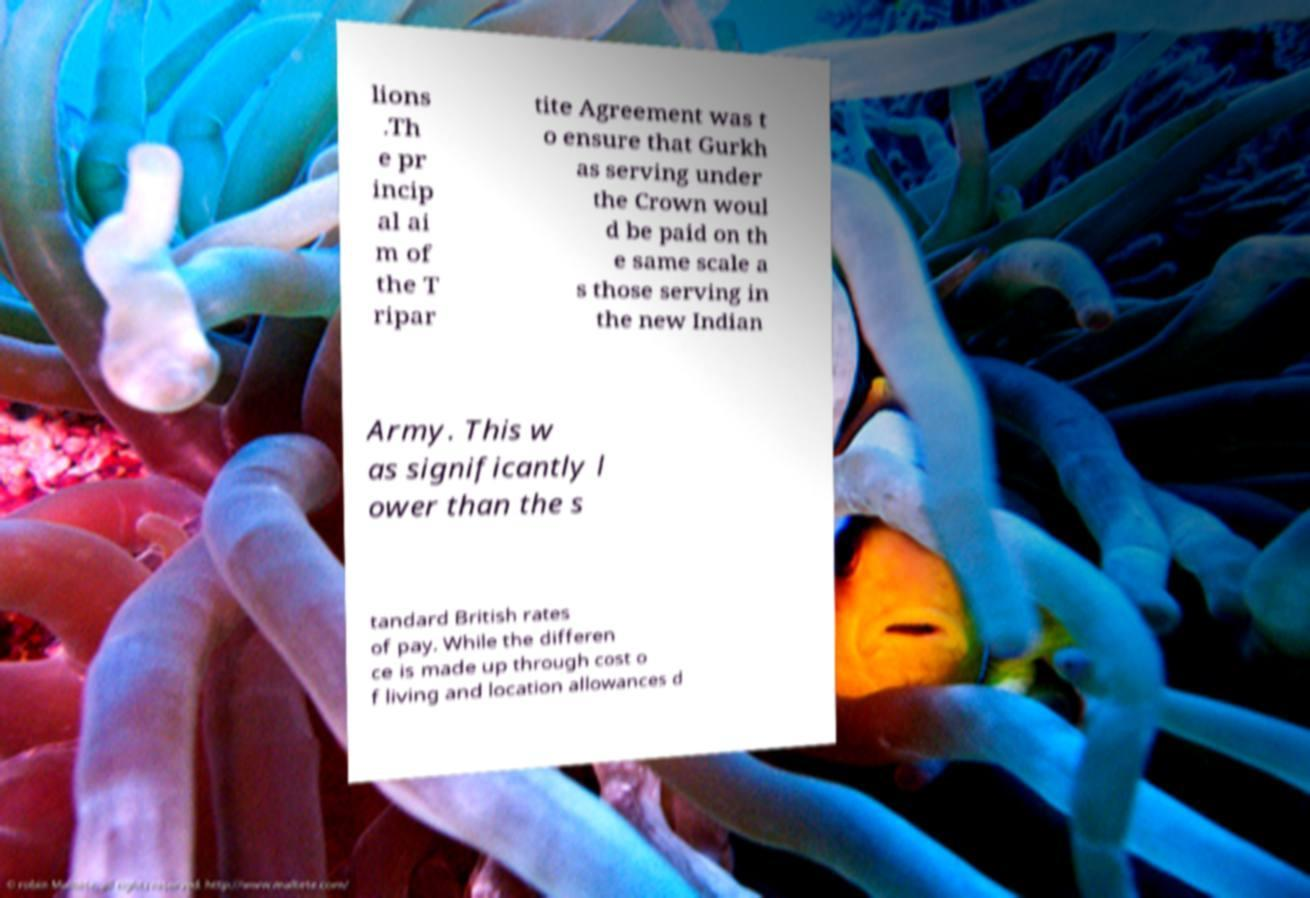Could you extract and type out the text from this image? lions .Th e pr incip al ai m of the T ripar tite Agreement was t o ensure that Gurkh as serving under the Crown woul d be paid on th e same scale a s those serving in the new Indian Army. This w as significantly l ower than the s tandard British rates of pay. While the differen ce is made up through cost o f living and location allowances d 